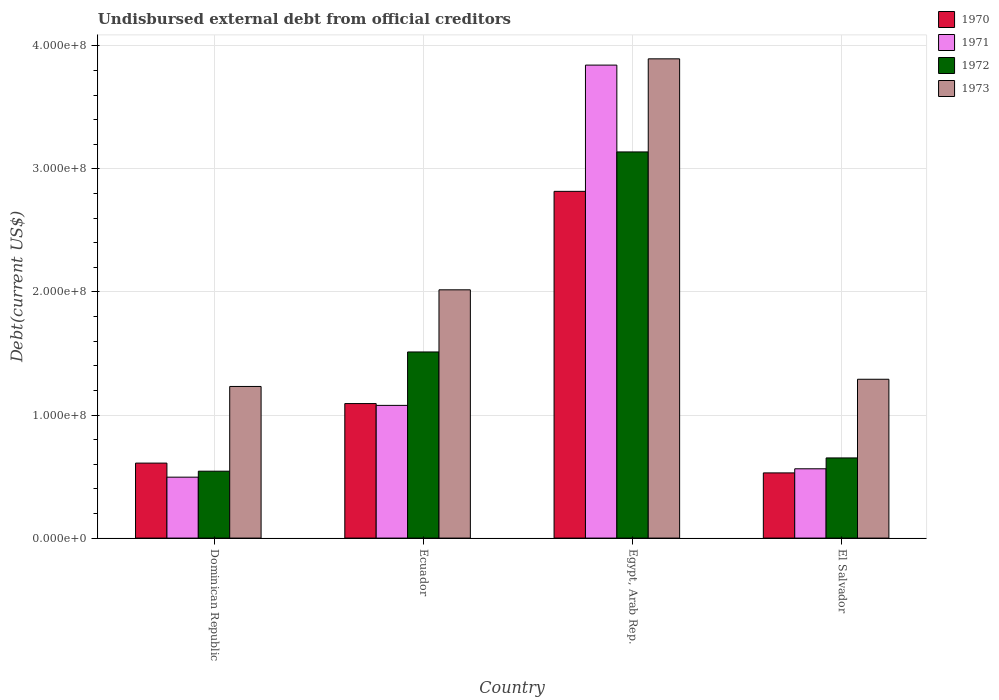How many different coloured bars are there?
Provide a succinct answer. 4. How many groups of bars are there?
Provide a succinct answer. 4. How many bars are there on the 3rd tick from the left?
Offer a terse response. 4. How many bars are there on the 3rd tick from the right?
Your answer should be compact. 4. What is the label of the 3rd group of bars from the left?
Your answer should be very brief. Egypt, Arab Rep. In how many cases, is the number of bars for a given country not equal to the number of legend labels?
Offer a terse response. 0. What is the total debt in 1970 in Egypt, Arab Rep.?
Provide a short and direct response. 2.82e+08. Across all countries, what is the maximum total debt in 1973?
Make the answer very short. 3.89e+08. Across all countries, what is the minimum total debt in 1972?
Keep it short and to the point. 5.44e+07. In which country was the total debt in 1973 maximum?
Keep it short and to the point. Egypt, Arab Rep. In which country was the total debt in 1971 minimum?
Offer a terse response. Dominican Republic. What is the total total debt in 1972 in the graph?
Make the answer very short. 5.84e+08. What is the difference between the total debt in 1971 in Egypt, Arab Rep. and that in El Salvador?
Ensure brevity in your answer.  3.28e+08. What is the difference between the total debt in 1972 in El Salvador and the total debt in 1973 in Egypt, Arab Rep.?
Provide a succinct answer. -3.24e+08. What is the average total debt in 1970 per country?
Offer a terse response. 1.26e+08. What is the difference between the total debt of/in 1972 and total debt of/in 1970 in Egypt, Arab Rep.?
Your answer should be compact. 3.20e+07. In how many countries, is the total debt in 1973 greater than 300000000 US$?
Your response must be concise. 1. What is the ratio of the total debt in 1971 in Ecuador to that in El Salvador?
Ensure brevity in your answer.  1.91. Is the total debt in 1973 in Dominican Republic less than that in Egypt, Arab Rep.?
Make the answer very short. Yes. What is the difference between the highest and the second highest total debt in 1971?
Provide a succinct answer. 2.76e+08. What is the difference between the highest and the lowest total debt in 1970?
Ensure brevity in your answer.  2.29e+08. Is the sum of the total debt in 1971 in Dominican Republic and Ecuador greater than the maximum total debt in 1973 across all countries?
Offer a terse response. No. What does the 4th bar from the left in Dominican Republic represents?
Your answer should be compact. 1973. What does the 1st bar from the right in El Salvador represents?
Offer a very short reply. 1973. Is it the case that in every country, the sum of the total debt in 1973 and total debt in 1971 is greater than the total debt in 1970?
Your answer should be compact. Yes. How many bars are there?
Your answer should be compact. 16. Are all the bars in the graph horizontal?
Provide a short and direct response. No. How many countries are there in the graph?
Provide a short and direct response. 4. Does the graph contain any zero values?
Make the answer very short. No. Where does the legend appear in the graph?
Make the answer very short. Top right. How are the legend labels stacked?
Ensure brevity in your answer.  Vertical. What is the title of the graph?
Provide a succinct answer. Undisbursed external debt from official creditors. Does "1976" appear as one of the legend labels in the graph?
Provide a succinct answer. No. What is the label or title of the Y-axis?
Give a very brief answer. Debt(current US$). What is the Debt(current US$) in 1970 in Dominican Republic?
Your response must be concise. 6.09e+07. What is the Debt(current US$) in 1971 in Dominican Republic?
Keep it short and to the point. 4.95e+07. What is the Debt(current US$) of 1972 in Dominican Republic?
Give a very brief answer. 5.44e+07. What is the Debt(current US$) in 1973 in Dominican Republic?
Your answer should be compact. 1.23e+08. What is the Debt(current US$) in 1970 in Ecuador?
Your answer should be compact. 1.09e+08. What is the Debt(current US$) in 1971 in Ecuador?
Your response must be concise. 1.08e+08. What is the Debt(current US$) of 1972 in Ecuador?
Give a very brief answer. 1.51e+08. What is the Debt(current US$) in 1973 in Ecuador?
Ensure brevity in your answer.  2.02e+08. What is the Debt(current US$) of 1970 in Egypt, Arab Rep.?
Your answer should be very brief. 2.82e+08. What is the Debt(current US$) in 1971 in Egypt, Arab Rep.?
Offer a very short reply. 3.84e+08. What is the Debt(current US$) in 1972 in Egypt, Arab Rep.?
Your answer should be compact. 3.14e+08. What is the Debt(current US$) in 1973 in Egypt, Arab Rep.?
Your answer should be compact. 3.89e+08. What is the Debt(current US$) in 1970 in El Salvador?
Provide a succinct answer. 5.30e+07. What is the Debt(current US$) in 1971 in El Salvador?
Offer a terse response. 5.63e+07. What is the Debt(current US$) of 1972 in El Salvador?
Give a very brief answer. 6.51e+07. What is the Debt(current US$) of 1973 in El Salvador?
Offer a terse response. 1.29e+08. Across all countries, what is the maximum Debt(current US$) in 1970?
Provide a short and direct response. 2.82e+08. Across all countries, what is the maximum Debt(current US$) in 1971?
Your response must be concise. 3.84e+08. Across all countries, what is the maximum Debt(current US$) of 1972?
Offer a very short reply. 3.14e+08. Across all countries, what is the maximum Debt(current US$) in 1973?
Give a very brief answer. 3.89e+08. Across all countries, what is the minimum Debt(current US$) in 1970?
Your response must be concise. 5.30e+07. Across all countries, what is the minimum Debt(current US$) in 1971?
Give a very brief answer. 4.95e+07. Across all countries, what is the minimum Debt(current US$) in 1972?
Offer a very short reply. 5.44e+07. Across all countries, what is the minimum Debt(current US$) in 1973?
Your answer should be compact. 1.23e+08. What is the total Debt(current US$) in 1970 in the graph?
Your answer should be very brief. 5.05e+08. What is the total Debt(current US$) of 1971 in the graph?
Make the answer very short. 5.98e+08. What is the total Debt(current US$) in 1972 in the graph?
Keep it short and to the point. 5.84e+08. What is the total Debt(current US$) of 1973 in the graph?
Ensure brevity in your answer.  8.43e+08. What is the difference between the Debt(current US$) of 1970 in Dominican Republic and that in Ecuador?
Your answer should be compact. -4.84e+07. What is the difference between the Debt(current US$) in 1971 in Dominican Republic and that in Ecuador?
Offer a terse response. -5.83e+07. What is the difference between the Debt(current US$) in 1972 in Dominican Republic and that in Ecuador?
Provide a succinct answer. -9.69e+07. What is the difference between the Debt(current US$) of 1973 in Dominican Republic and that in Ecuador?
Offer a terse response. -7.85e+07. What is the difference between the Debt(current US$) in 1970 in Dominican Republic and that in Egypt, Arab Rep.?
Keep it short and to the point. -2.21e+08. What is the difference between the Debt(current US$) in 1971 in Dominican Republic and that in Egypt, Arab Rep.?
Ensure brevity in your answer.  -3.35e+08. What is the difference between the Debt(current US$) in 1972 in Dominican Republic and that in Egypt, Arab Rep.?
Provide a succinct answer. -2.59e+08. What is the difference between the Debt(current US$) in 1973 in Dominican Republic and that in Egypt, Arab Rep.?
Your response must be concise. -2.66e+08. What is the difference between the Debt(current US$) in 1970 in Dominican Republic and that in El Salvador?
Ensure brevity in your answer.  7.96e+06. What is the difference between the Debt(current US$) in 1971 in Dominican Republic and that in El Salvador?
Provide a short and direct response. -6.81e+06. What is the difference between the Debt(current US$) in 1972 in Dominican Republic and that in El Salvador?
Give a very brief answer. -1.08e+07. What is the difference between the Debt(current US$) of 1973 in Dominican Republic and that in El Salvador?
Your answer should be compact. -5.85e+06. What is the difference between the Debt(current US$) in 1970 in Ecuador and that in Egypt, Arab Rep.?
Ensure brevity in your answer.  -1.72e+08. What is the difference between the Debt(current US$) in 1971 in Ecuador and that in Egypt, Arab Rep.?
Your answer should be very brief. -2.76e+08. What is the difference between the Debt(current US$) in 1972 in Ecuador and that in Egypt, Arab Rep.?
Provide a succinct answer. -1.63e+08. What is the difference between the Debt(current US$) in 1973 in Ecuador and that in Egypt, Arab Rep.?
Make the answer very short. -1.88e+08. What is the difference between the Debt(current US$) in 1970 in Ecuador and that in El Salvador?
Your response must be concise. 5.63e+07. What is the difference between the Debt(current US$) in 1971 in Ecuador and that in El Salvador?
Offer a very short reply. 5.15e+07. What is the difference between the Debt(current US$) in 1972 in Ecuador and that in El Salvador?
Ensure brevity in your answer.  8.61e+07. What is the difference between the Debt(current US$) of 1973 in Ecuador and that in El Salvador?
Provide a succinct answer. 7.27e+07. What is the difference between the Debt(current US$) of 1970 in Egypt, Arab Rep. and that in El Salvador?
Your answer should be very brief. 2.29e+08. What is the difference between the Debt(current US$) of 1971 in Egypt, Arab Rep. and that in El Salvador?
Offer a very short reply. 3.28e+08. What is the difference between the Debt(current US$) in 1972 in Egypt, Arab Rep. and that in El Salvador?
Your response must be concise. 2.49e+08. What is the difference between the Debt(current US$) in 1973 in Egypt, Arab Rep. and that in El Salvador?
Keep it short and to the point. 2.60e+08. What is the difference between the Debt(current US$) of 1970 in Dominican Republic and the Debt(current US$) of 1971 in Ecuador?
Make the answer very short. -4.69e+07. What is the difference between the Debt(current US$) of 1970 in Dominican Republic and the Debt(current US$) of 1972 in Ecuador?
Keep it short and to the point. -9.03e+07. What is the difference between the Debt(current US$) in 1970 in Dominican Republic and the Debt(current US$) in 1973 in Ecuador?
Give a very brief answer. -1.41e+08. What is the difference between the Debt(current US$) of 1971 in Dominican Republic and the Debt(current US$) of 1972 in Ecuador?
Give a very brief answer. -1.02e+08. What is the difference between the Debt(current US$) of 1971 in Dominican Republic and the Debt(current US$) of 1973 in Ecuador?
Ensure brevity in your answer.  -1.52e+08. What is the difference between the Debt(current US$) of 1972 in Dominican Republic and the Debt(current US$) of 1973 in Ecuador?
Give a very brief answer. -1.47e+08. What is the difference between the Debt(current US$) of 1970 in Dominican Republic and the Debt(current US$) of 1971 in Egypt, Arab Rep.?
Offer a terse response. -3.23e+08. What is the difference between the Debt(current US$) of 1970 in Dominican Republic and the Debt(current US$) of 1972 in Egypt, Arab Rep.?
Your answer should be very brief. -2.53e+08. What is the difference between the Debt(current US$) of 1970 in Dominican Republic and the Debt(current US$) of 1973 in Egypt, Arab Rep.?
Provide a short and direct response. -3.28e+08. What is the difference between the Debt(current US$) of 1971 in Dominican Republic and the Debt(current US$) of 1972 in Egypt, Arab Rep.?
Offer a very short reply. -2.64e+08. What is the difference between the Debt(current US$) of 1971 in Dominican Republic and the Debt(current US$) of 1973 in Egypt, Arab Rep.?
Your response must be concise. -3.40e+08. What is the difference between the Debt(current US$) in 1972 in Dominican Republic and the Debt(current US$) in 1973 in Egypt, Arab Rep.?
Offer a very short reply. -3.35e+08. What is the difference between the Debt(current US$) of 1970 in Dominican Republic and the Debt(current US$) of 1971 in El Salvador?
Give a very brief answer. 4.62e+06. What is the difference between the Debt(current US$) of 1970 in Dominican Republic and the Debt(current US$) of 1972 in El Salvador?
Ensure brevity in your answer.  -4.20e+06. What is the difference between the Debt(current US$) in 1970 in Dominican Republic and the Debt(current US$) in 1973 in El Salvador?
Make the answer very short. -6.81e+07. What is the difference between the Debt(current US$) of 1971 in Dominican Republic and the Debt(current US$) of 1972 in El Salvador?
Ensure brevity in your answer.  -1.56e+07. What is the difference between the Debt(current US$) in 1971 in Dominican Republic and the Debt(current US$) in 1973 in El Salvador?
Offer a terse response. -7.95e+07. What is the difference between the Debt(current US$) in 1972 in Dominican Republic and the Debt(current US$) in 1973 in El Salvador?
Make the answer very short. -7.47e+07. What is the difference between the Debt(current US$) in 1970 in Ecuador and the Debt(current US$) in 1971 in Egypt, Arab Rep.?
Provide a succinct answer. -2.75e+08. What is the difference between the Debt(current US$) in 1970 in Ecuador and the Debt(current US$) in 1972 in Egypt, Arab Rep.?
Offer a terse response. -2.04e+08. What is the difference between the Debt(current US$) of 1970 in Ecuador and the Debt(current US$) of 1973 in Egypt, Arab Rep.?
Give a very brief answer. -2.80e+08. What is the difference between the Debt(current US$) in 1971 in Ecuador and the Debt(current US$) in 1972 in Egypt, Arab Rep.?
Offer a terse response. -2.06e+08. What is the difference between the Debt(current US$) of 1971 in Ecuador and the Debt(current US$) of 1973 in Egypt, Arab Rep.?
Provide a succinct answer. -2.82e+08. What is the difference between the Debt(current US$) of 1972 in Ecuador and the Debt(current US$) of 1973 in Egypt, Arab Rep.?
Make the answer very short. -2.38e+08. What is the difference between the Debt(current US$) of 1970 in Ecuador and the Debt(current US$) of 1971 in El Salvador?
Give a very brief answer. 5.30e+07. What is the difference between the Debt(current US$) in 1970 in Ecuador and the Debt(current US$) in 1972 in El Salvador?
Your answer should be compact. 4.42e+07. What is the difference between the Debt(current US$) in 1970 in Ecuador and the Debt(current US$) in 1973 in El Salvador?
Keep it short and to the point. -1.98e+07. What is the difference between the Debt(current US$) of 1971 in Ecuador and the Debt(current US$) of 1972 in El Salvador?
Your answer should be compact. 4.27e+07. What is the difference between the Debt(current US$) of 1971 in Ecuador and the Debt(current US$) of 1973 in El Salvador?
Your answer should be very brief. -2.12e+07. What is the difference between the Debt(current US$) of 1972 in Ecuador and the Debt(current US$) of 1973 in El Salvador?
Offer a very short reply. 2.22e+07. What is the difference between the Debt(current US$) in 1970 in Egypt, Arab Rep. and the Debt(current US$) in 1971 in El Salvador?
Ensure brevity in your answer.  2.25e+08. What is the difference between the Debt(current US$) of 1970 in Egypt, Arab Rep. and the Debt(current US$) of 1972 in El Salvador?
Your answer should be very brief. 2.17e+08. What is the difference between the Debt(current US$) in 1970 in Egypt, Arab Rep. and the Debt(current US$) in 1973 in El Salvador?
Your response must be concise. 1.53e+08. What is the difference between the Debt(current US$) of 1971 in Egypt, Arab Rep. and the Debt(current US$) of 1972 in El Salvador?
Ensure brevity in your answer.  3.19e+08. What is the difference between the Debt(current US$) in 1971 in Egypt, Arab Rep. and the Debt(current US$) in 1973 in El Salvador?
Ensure brevity in your answer.  2.55e+08. What is the difference between the Debt(current US$) in 1972 in Egypt, Arab Rep. and the Debt(current US$) in 1973 in El Salvador?
Keep it short and to the point. 1.85e+08. What is the average Debt(current US$) of 1970 per country?
Make the answer very short. 1.26e+08. What is the average Debt(current US$) of 1971 per country?
Offer a very short reply. 1.49e+08. What is the average Debt(current US$) in 1972 per country?
Your answer should be compact. 1.46e+08. What is the average Debt(current US$) in 1973 per country?
Provide a succinct answer. 2.11e+08. What is the difference between the Debt(current US$) in 1970 and Debt(current US$) in 1971 in Dominican Republic?
Keep it short and to the point. 1.14e+07. What is the difference between the Debt(current US$) in 1970 and Debt(current US$) in 1972 in Dominican Republic?
Provide a succinct answer. 6.57e+06. What is the difference between the Debt(current US$) of 1970 and Debt(current US$) of 1973 in Dominican Republic?
Your response must be concise. -6.23e+07. What is the difference between the Debt(current US$) in 1971 and Debt(current US$) in 1972 in Dominican Republic?
Your answer should be very brief. -4.85e+06. What is the difference between the Debt(current US$) in 1971 and Debt(current US$) in 1973 in Dominican Republic?
Provide a succinct answer. -7.37e+07. What is the difference between the Debt(current US$) in 1972 and Debt(current US$) in 1973 in Dominican Republic?
Make the answer very short. -6.88e+07. What is the difference between the Debt(current US$) of 1970 and Debt(current US$) of 1971 in Ecuador?
Your answer should be compact. 1.47e+06. What is the difference between the Debt(current US$) of 1970 and Debt(current US$) of 1972 in Ecuador?
Make the answer very short. -4.19e+07. What is the difference between the Debt(current US$) in 1970 and Debt(current US$) in 1973 in Ecuador?
Your response must be concise. -9.24e+07. What is the difference between the Debt(current US$) in 1971 and Debt(current US$) in 1972 in Ecuador?
Provide a succinct answer. -4.34e+07. What is the difference between the Debt(current US$) in 1971 and Debt(current US$) in 1973 in Ecuador?
Ensure brevity in your answer.  -9.39e+07. What is the difference between the Debt(current US$) of 1972 and Debt(current US$) of 1973 in Ecuador?
Your answer should be very brief. -5.05e+07. What is the difference between the Debt(current US$) in 1970 and Debt(current US$) in 1971 in Egypt, Arab Rep.?
Offer a terse response. -1.03e+08. What is the difference between the Debt(current US$) in 1970 and Debt(current US$) in 1972 in Egypt, Arab Rep.?
Provide a succinct answer. -3.20e+07. What is the difference between the Debt(current US$) in 1970 and Debt(current US$) in 1973 in Egypt, Arab Rep.?
Your answer should be compact. -1.08e+08. What is the difference between the Debt(current US$) of 1971 and Debt(current US$) of 1972 in Egypt, Arab Rep.?
Your answer should be very brief. 7.06e+07. What is the difference between the Debt(current US$) of 1971 and Debt(current US$) of 1973 in Egypt, Arab Rep.?
Your response must be concise. -5.09e+06. What is the difference between the Debt(current US$) in 1972 and Debt(current US$) in 1973 in Egypt, Arab Rep.?
Keep it short and to the point. -7.56e+07. What is the difference between the Debt(current US$) of 1970 and Debt(current US$) of 1971 in El Salvador?
Keep it short and to the point. -3.35e+06. What is the difference between the Debt(current US$) in 1970 and Debt(current US$) in 1972 in El Salvador?
Make the answer very short. -1.22e+07. What is the difference between the Debt(current US$) in 1970 and Debt(current US$) in 1973 in El Salvador?
Your answer should be compact. -7.61e+07. What is the difference between the Debt(current US$) in 1971 and Debt(current US$) in 1972 in El Salvador?
Offer a terse response. -8.81e+06. What is the difference between the Debt(current US$) of 1971 and Debt(current US$) of 1973 in El Salvador?
Your response must be concise. -7.27e+07. What is the difference between the Debt(current US$) in 1972 and Debt(current US$) in 1973 in El Salvador?
Provide a short and direct response. -6.39e+07. What is the ratio of the Debt(current US$) of 1970 in Dominican Republic to that in Ecuador?
Offer a very short reply. 0.56. What is the ratio of the Debt(current US$) of 1971 in Dominican Republic to that in Ecuador?
Your answer should be very brief. 0.46. What is the ratio of the Debt(current US$) of 1972 in Dominican Republic to that in Ecuador?
Ensure brevity in your answer.  0.36. What is the ratio of the Debt(current US$) in 1973 in Dominican Republic to that in Ecuador?
Offer a terse response. 0.61. What is the ratio of the Debt(current US$) in 1970 in Dominican Republic to that in Egypt, Arab Rep.?
Your response must be concise. 0.22. What is the ratio of the Debt(current US$) of 1971 in Dominican Republic to that in Egypt, Arab Rep.?
Your response must be concise. 0.13. What is the ratio of the Debt(current US$) in 1972 in Dominican Republic to that in Egypt, Arab Rep.?
Your answer should be very brief. 0.17. What is the ratio of the Debt(current US$) in 1973 in Dominican Republic to that in Egypt, Arab Rep.?
Provide a succinct answer. 0.32. What is the ratio of the Debt(current US$) in 1970 in Dominican Republic to that in El Salvador?
Provide a succinct answer. 1.15. What is the ratio of the Debt(current US$) in 1971 in Dominican Republic to that in El Salvador?
Your answer should be compact. 0.88. What is the ratio of the Debt(current US$) of 1972 in Dominican Republic to that in El Salvador?
Your response must be concise. 0.83. What is the ratio of the Debt(current US$) in 1973 in Dominican Republic to that in El Salvador?
Your response must be concise. 0.95. What is the ratio of the Debt(current US$) of 1970 in Ecuador to that in Egypt, Arab Rep.?
Make the answer very short. 0.39. What is the ratio of the Debt(current US$) in 1971 in Ecuador to that in Egypt, Arab Rep.?
Your response must be concise. 0.28. What is the ratio of the Debt(current US$) in 1972 in Ecuador to that in Egypt, Arab Rep.?
Offer a terse response. 0.48. What is the ratio of the Debt(current US$) in 1973 in Ecuador to that in Egypt, Arab Rep.?
Ensure brevity in your answer.  0.52. What is the ratio of the Debt(current US$) in 1970 in Ecuador to that in El Salvador?
Your answer should be compact. 2.06. What is the ratio of the Debt(current US$) in 1971 in Ecuador to that in El Salvador?
Keep it short and to the point. 1.91. What is the ratio of the Debt(current US$) in 1972 in Ecuador to that in El Salvador?
Your response must be concise. 2.32. What is the ratio of the Debt(current US$) in 1973 in Ecuador to that in El Salvador?
Offer a very short reply. 1.56. What is the ratio of the Debt(current US$) of 1970 in Egypt, Arab Rep. to that in El Salvador?
Ensure brevity in your answer.  5.32. What is the ratio of the Debt(current US$) of 1971 in Egypt, Arab Rep. to that in El Salvador?
Make the answer very short. 6.82. What is the ratio of the Debt(current US$) in 1972 in Egypt, Arab Rep. to that in El Salvador?
Keep it short and to the point. 4.82. What is the ratio of the Debt(current US$) of 1973 in Egypt, Arab Rep. to that in El Salvador?
Your answer should be very brief. 3.02. What is the difference between the highest and the second highest Debt(current US$) in 1970?
Give a very brief answer. 1.72e+08. What is the difference between the highest and the second highest Debt(current US$) of 1971?
Keep it short and to the point. 2.76e+08. What is the difference between the highest and the second highest Debt(current US$) of 1972?
Make the answer very short. 1.63e+08. What is the difference between the highest and the second highest Debt(current US$) of 1973?
Offer a very short reply. 1.88e+08. What is the difference between the highest and the lowest Debt(current US$) in 1970?
Offer a terse response. 2.29e+08. What is the difference between the highest and the lowest Debt(current US$) of 1971?
Ensure brevity in your answer.  3.35e+08. What is the difference between the highest and the lowest Debt(current US$) in 1972?
Ensure brevity in your answer.  2.59e+08. What is the difference between the highest and the lowest Debt(current US$) in 1973?
Your answer should be very brief. 2.66e+08. 